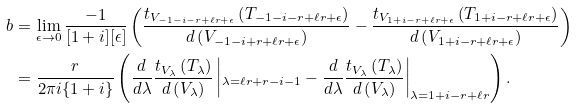Convert formula to latex. <formula><loc_0><loc_0><loc_500><loc_500>b & = \lim _ { \epsilon \to 0 } \frac { - 1 } { [ 1 + i ] [ \epsilon ] } \left ( \frac { t _ { V _ { - 1 - i - r + \ell r + \epsilon } } \left ( T _ { - 1 - i - r + \ell r + \epsilon } \right ) } { d \left ( V _ { - 1 - i + r + \ell r + \epsilon } \right ) } - \frac { t _ { V _ { 1 + i - r + \ell r + \epsilon } } \left ( T _ { 1 + i - r + \ell r + \epsilon } \right ) } { d \left ( V _ { 1 + i - r + \ell r + \epsilon } \right ) } \right ) \\ & = \frac { r } { 2 \pi i \{ 1 + i \} } \left ( \frac { d } { d \lambda } \frac { t _ { V _ { \lambda } } \left ( T _ { \lambda } \right ) } { d \left ( V _ { \lambda } \right ) } \left | _ { \lambda = \ell r + r - i - 1 } - \frac { d } { d \lambda } \frac { t _ { V _ { \lambda } } \left ( T _ { \lambda } \right ) } { d \left ( V _ { \lambda } \right ) } \right | _ { \lambda = 1 + i - r + \ell r } \right ) .</formula> 